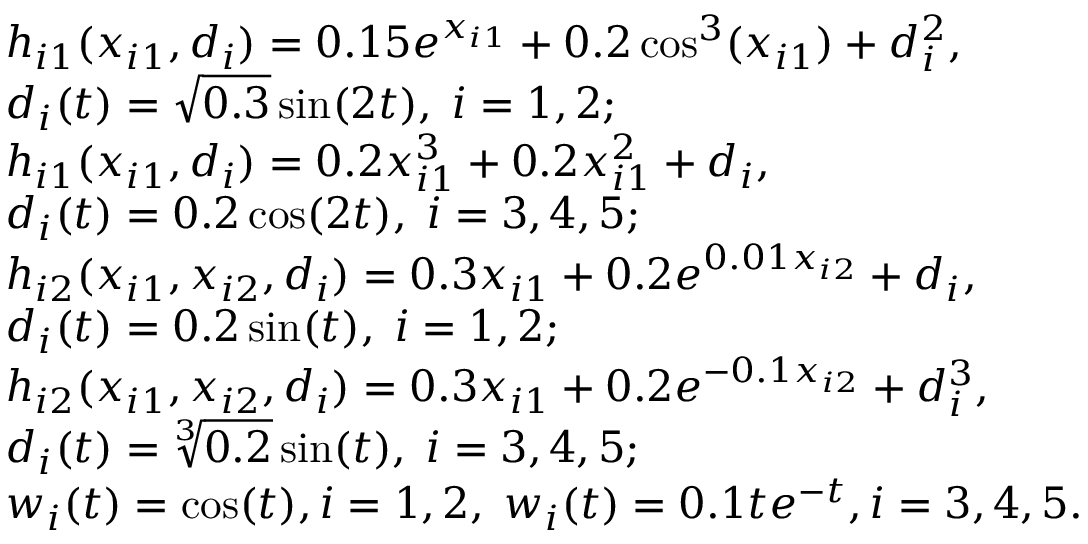<formula> <loc_0><loc_0><loc_500><loc_500>\begin{array} { r l } & { h _ { i 1 } ( x _ { i 1 } , d _ { i } ) = 0 . 1 5 e ^ { x _ { i 1 } } + 0 . 2 \cos ^ { 3 } ( x _ { i 1 } ) + d _ { i } ^ { 2 } , } \\ & { d _ { i } ( t ) = \sqrt { 0 . 3 } \sin ( 2 t ) , \, i = 1 , 2 ; } \\ & { h _ { i 1 } ( x _ { i 1 } , d _ { i } ) = 0 . 2 x _ { i 1 } ^ { 3 } + 0 . 2 x _ { i 1 } ^ { 2 } + d _ { i } , } \\ & { d _ { i } ( t ) = 0 . 2 \cos ( 2 t ) , \, i = 3 , 4 , 5 ; } \\ & { h _ { i 2 } ( x _ { i 1 } , x _ { i 2 } , d _ { i } ) = 0 . 3 x _ { i 1 } + 0 . 2 e ^ { 0 . 0 1 x _ { i 2 } } + d _ { i } , } \\ & { d _ { i } ( t ) = 0 . 2 \sin ( t ) , \, i = 1 , 2 ; } \\ & { h _ { i 2 } ( x _ { i 1 } , x _ { i 2 } , d _ { i } ) = 0 . 3 x _ { i 1 } + 0 . 2 e ^ { - 0 . 1 x _ { i 2 } } + d _ { i } ^ { 3 } , } \\ & { d _ { i } ( t ) = \sqrt { [ } 3 ] { 0 . 2 } \sin ( t ) , \, i = 3 , 4 , 5 ; } \\ & { w _ { i } ( t ) = \cos ( t ) , i = 1 , 2 , \, w _ { i } ( t ) = 0 . 1 t e ^ { - t } , i = 3 , 4 , 5 . } \end{array}</formula> 